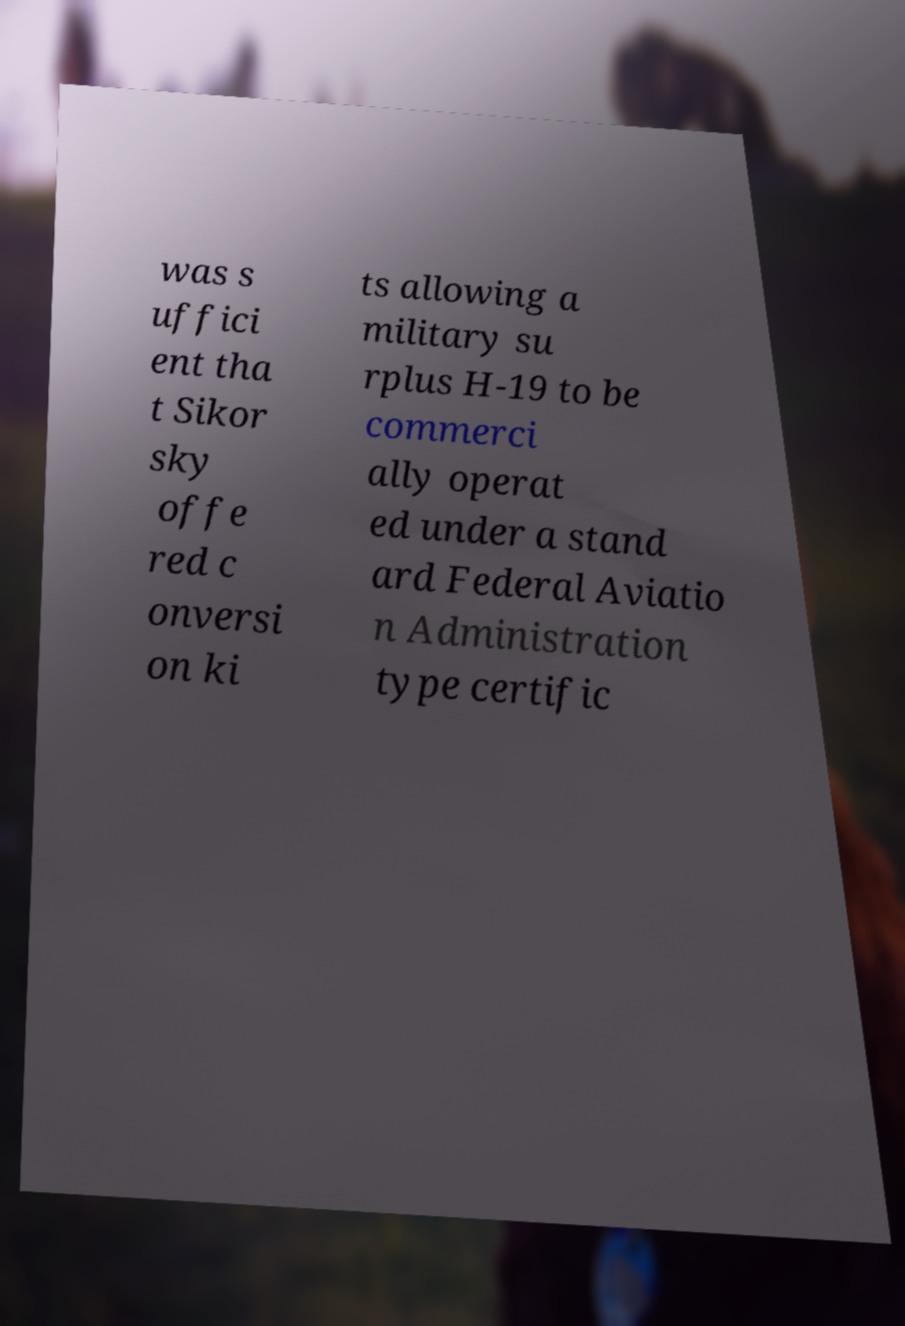Please identify and transcribe the text found in this image. was s uffici ent tha t Sikor sky offe red c onversi on ki ts allowing a military su rplus H-19 to be commerci ally operat ed under a stand ard Federal Aviatio n Administration type certific 